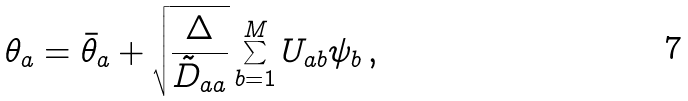Convert formula to latex. <formula><loc_0><loc_0><loc_500><loc_500>\theta _ { a } = \bar { \theta } _ { a } + \sqrt { \frac { \Delta } { \tilde { D } _ { a a } } } \sum _ { b = 1 } ^ { M } U _ { a b } \psi _ { b } \, ,</formula> 